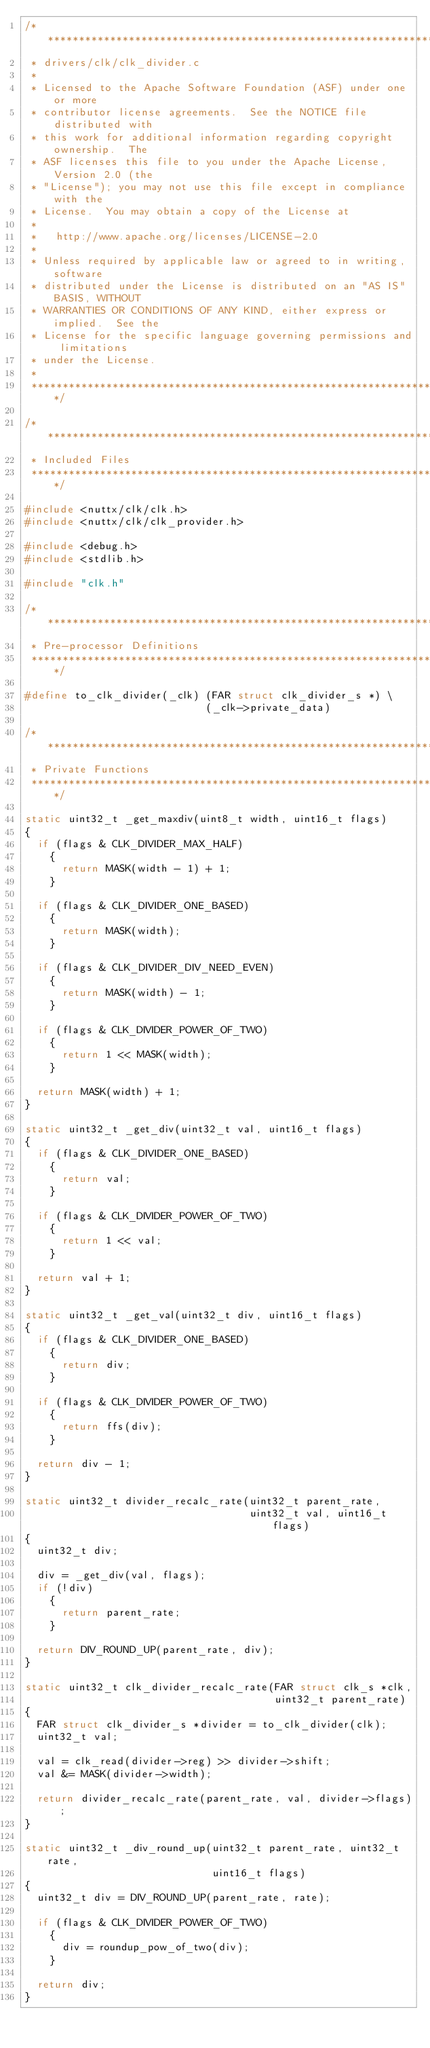Convert code to text. <code><loc_0><loc_0><loc_500><loc_500><_C_>/****************************************************************************
 * drivers/clk/clk_divider.c
 *
 * Licensed to the Apache Software Foundation (ASF) under one or more
 * contributor license agreements.  See the NOTICE file distributed with
 * this work for additional information regarding copyright ownership.  The
 * ASF licenses this file to you under the Apache License, Version 2.0 (the
 * "License"); you may not use this file except in compliance with the
 * License.  You may obtain a copy of the License at
 *
 *   http://www.apache.org/licenses/LICENSE-2.0
 *
 * Unless required by applicable law or agreed to in writing, software
 * distributed under the License is distributed on an "AS IS" BASIS, WITHOUT
 * WARRANTIES OR CONDITIONS OF ANY KIND, either express or implied.  See the
 * License for the specific language governing permissions and limitations
 * under the License.
 *
 ****************************************************************************/

/****************************************************************************
 * Included Files
 ****************************************************************************/

#include <nuttx/clk/clk.h>
#include <nuttx/clk/clk_provider.h>

#include <debug.h>
#include <stdlib.h>

#include "clk.h"

/****************************************************************************
 * Pre-processor Definitions
 ****************************************************************************/

#define to_clk_divider(_clk) (FAR struct clk_divider_s *) \
                             (_clk->private_data)

/****************************************************************************
 * Private Functions
 ****************************************************************************/

static uint32_t _get_maxdiv(uint8_t width, uint16_t flags)
{
  if (flags & CLK_DIVIDER_MAX_HALF)
    {
      return MASK(width - 1) + 1;
    }

  if (flags & CLK_DIVIDER_ONE_BASED)
    {
      return MASK(width);
    }

  if (flags & CLK_DIVIDER_DIV_NEED_EVEN)
    {
      return MASK(width) - 1;
    }

  if (flags & CLK_DIVIDER_POWER_OF_TWO)
    {
      return 1 << MASK(width);
    }

  return MASK(width) + 1;
}

static uint32_t _get_div(uint32_t val, uint16_t flags)
{
  if (flags & CLK_DIVIDER_ONE_BASED)
    {
      return val;
    }

  if (flags & CLK_DIVIDER_POWER_OF_TWO)
    {
      return 1 << val;
    }

  return val + 1;
}

static uint32_t _get_val(uint32_t div, uint16_t flags)
{
  if (flags & CLK_DIVIDER_ONE_BASED)
    {
      return div;
    }

  if (flags & CLK_DIVIDER_POWER_OF_TWO)
    {
      return ffs(div);
    }

  return div - 1;
}

static uint32_t divider_recalc_rate(uint32_t parent_rate,
                                    uint32_t val, uint16_t flags)
{
  uint32_t div;

  div = _get_div(val, flags);
  if (!div)
    {
      return parent_rate;
    }

  return DIV_ROUND_UP(parent_rate, div);
}

static uint32_t clk_divider_recalc_rate(FAR struct clk_s *clk,
                                        uint32_t parent_rate)
{
  FAR struct clk_divider_s *divider = to_clk_divider(clk);
  uint32_t val;

  val = clk_read(divider->reg) >> divider->shift;
  val &= MASK(divider->width);

  return divider_recalc_rate(parent_rate, val, divider->flags);
}

static uint32_t _div_round_up(uint32_t parent_rate, uint32_t rate,
                              uint16_t flags)
{
  uint32_t div = DIV_ROUND_UP(parent_rate, rate);

  if (flags & CLK_DIVIDER_POWER_OF_TWO)
    {
      div = roundup_pow_of_two(div);
    }

  return div;
}
</code> 